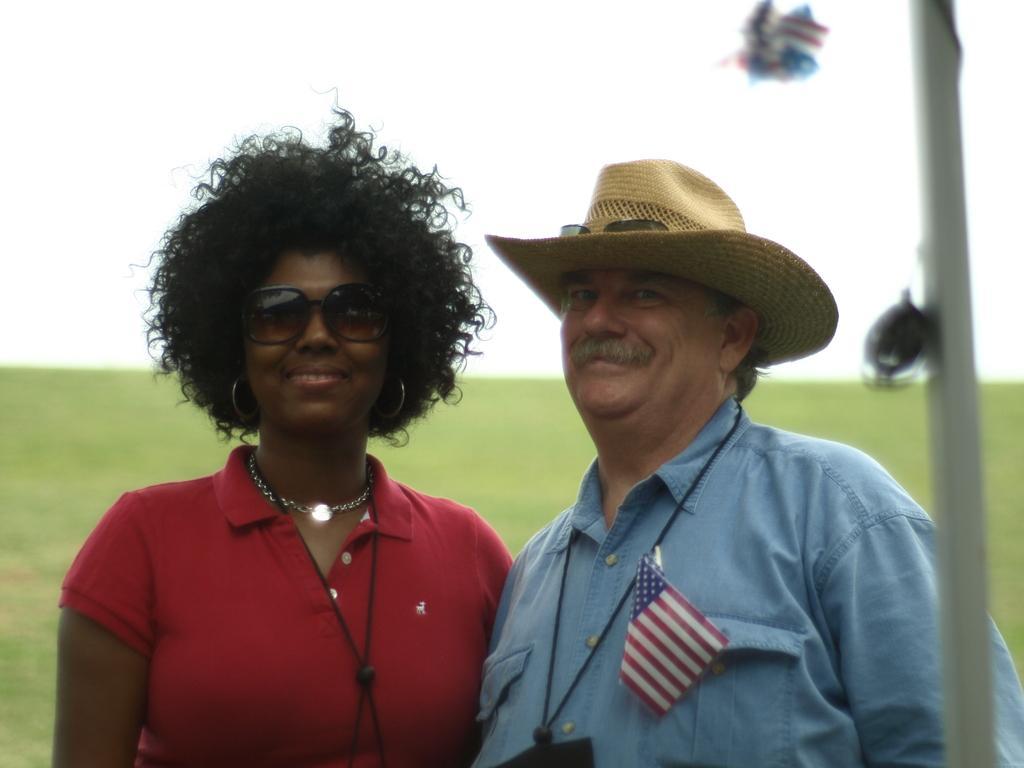Describe this image in one or two sentences. In this picture we can see two people smiling, flag, hat, goggles, some objects and in the background we can see the grass and the sky. 